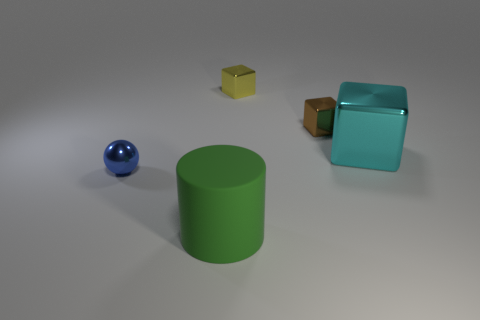Add 3 tiny brown cubes. How many objects exist? 8 Subtract all large cubes. How many cubes are left? 2 Subtract all cylinders. How many objects are left? 4 Add 3 yellow shiny cubes. How many yellow shiny cubes are left? 4 Add 1 small green spheres. How many small green spheres exist? 1 Subtract 0 yellow balls. How many objects are left? 5 Subtract all red cubes. Subtract all red cylinders. How many cubes are left? 3 Subtract all tiny brown things. Subtract all small balls. How many objects are left? 3 